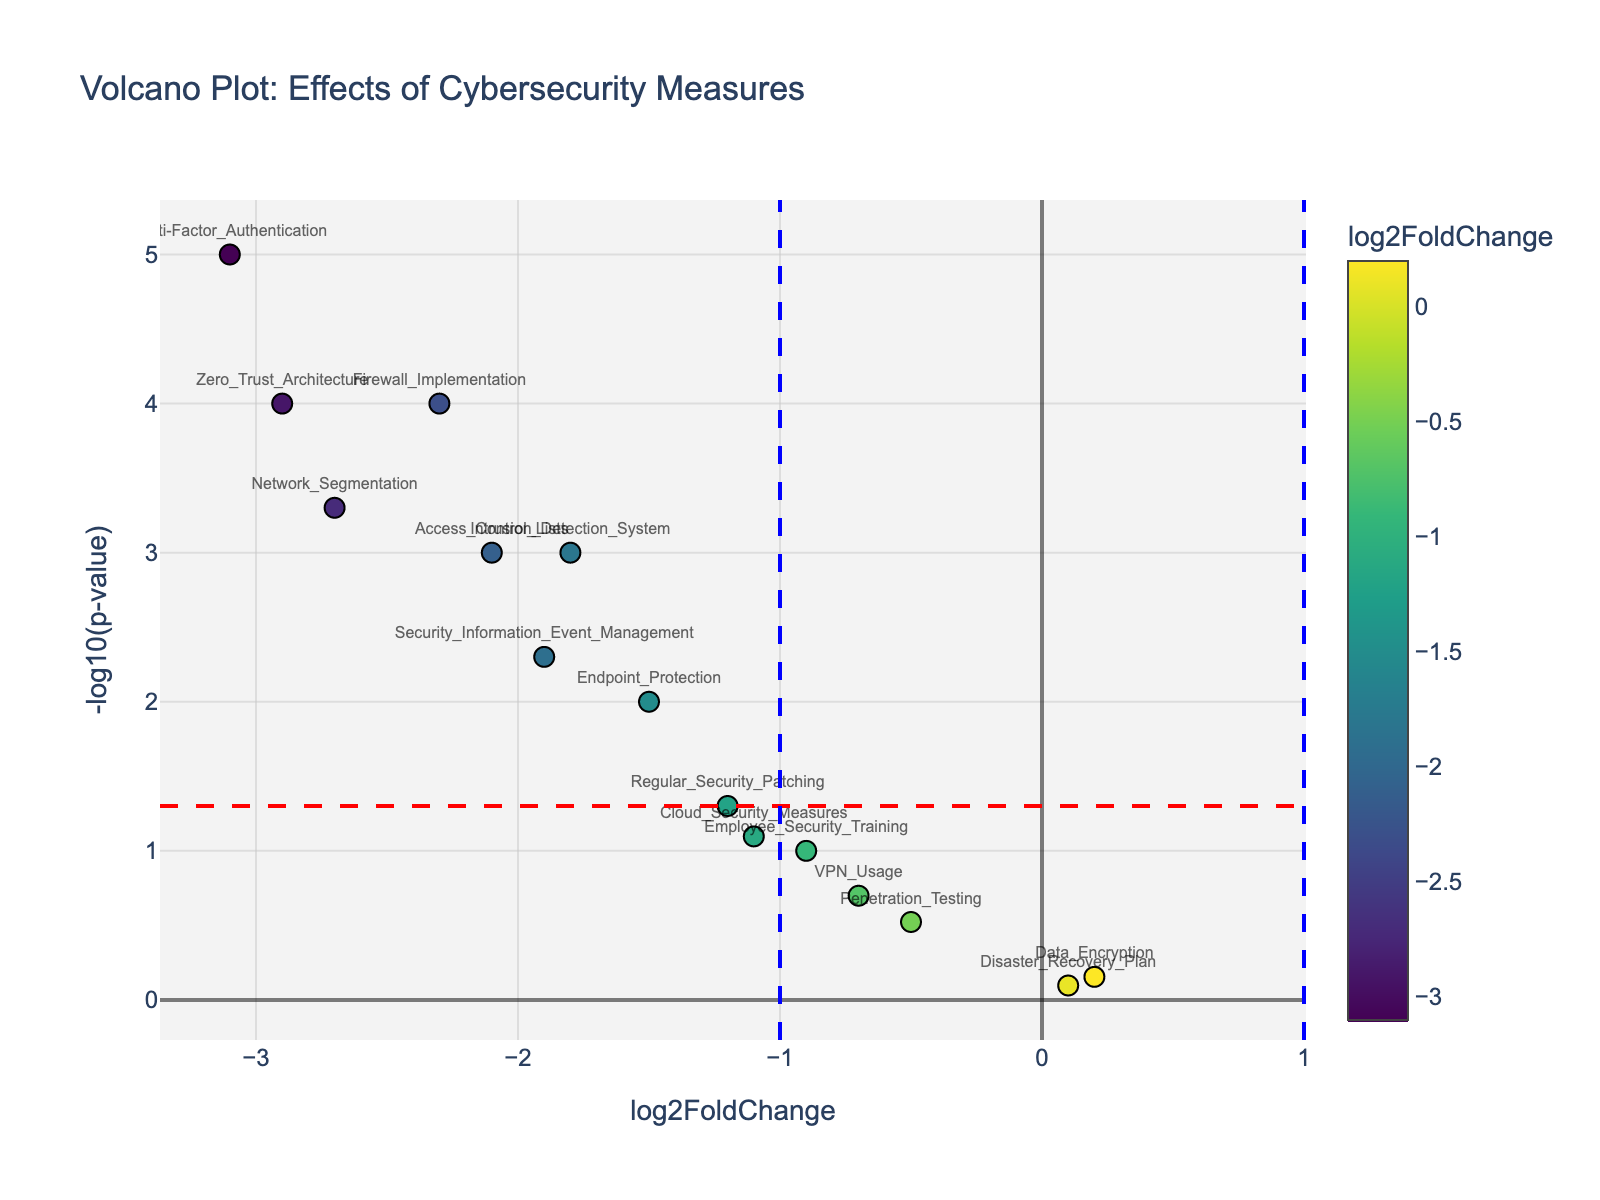What does the title of the plot indicate? The title of the plot indicates the main focus of the data visualization, which in this case is the effects of different cybersecurity measures on network intrusion attempts and successful breaches. By reading the title, you understand that each data point represents a cybersecurity measure, with its effectiveness and significance visualized.
Answer: Effects of Cybersecurity Measures on Network Intrusion Attempts and Successful Breaches Which measure has the highest -log10(p-value) and what is its value? To find the highest -log10(p-value), look for the data point with the highest position on the y-axis. The highest data point appears to be Multi-Factor Authentication, which has the highest -log10(p-value) value.
Answer: Multi-Factor Authentication, 5 How many measures are considered statistically significant (p-value < 0.05)? To determine the statistically significant measures, look for data points above the red horizontal line (which indicates a p-value of 0.05). Counting all the points above this line shows that there are 8 measures considered statistically significant.
Answer: 8 Which cybersecurity measure exhibits the strongest negative effect on network intrusion attempts? The measure with the strongest negative effect is the one with the largest negative log2FoldChange value. By examining the x-axis for the most leftward point, it is found that Multi-Factor Authentication has the strongest negative effect.
Answer: Multi-Factor Authentication What are the approximate log2FoldChange values for Data Encryption and VPN Usage? To find the approximate log2FoldChange values for Data Encryption and VPN Usage, locate these measures on the x-axis and read their positions. Data Encryption is around 0.2, and VPN Usage is around -0.7.
Answer: Data Encryption: 0.2, VPN Usage: -0.7 Which measure has the lowest statistical significance but still results in a negative log2FoldChange? To identify the measure with the lowest statistical significance (highest p-value) that still has a negative log2FoldChange, look for the data point closest to the bottom of the graph below the red line, yet towards the left. This is likely Employee Security Training.
Answer: Employee Security Training Compare the log2FoldChange values of Network Segmentation and Endpoint Protection. Which one has a lower value? To compare, find the positions of Network Segmentation and Endpoint Protection on the x-axis. Network Segmentation has a log2FoldChange of -2.7 while Endpoint Protection has -1.5, meaning Network Segmentation has a lower value.
Answer: Network Segmentation What is the interpretation of a positive log2FoldChange in this context? A positive log2FoldChange indicates an increase in network intrusion attempts or successful breaches when using the corresponding cybersecurity measure, implying that the measure might not be effective or could even be counterproductive in reducing these incidents.
Answer: Increase in network intrusion attempts Are there any measures that do not show a statistically significant effect but still indicate potential importance based on log2FoldChange? To determine this, consider measures where the p-value is greater than 0.05 (below the red threshold line) yet still have a substantial log2FoldChange. Cloud Security Measures with -1.1 shows a potential importance despite not being statistically significant.
Answer: Cloud Security Measures What is the average log2FoldChange for all measures that are statistically significant? First, identify the log2FoldChange for statistically significant measures (p-value < 0.05). These measures are: Firewall Implementation (-2.3), Intrusion Detection System (-1.8), Multi-Factor Authentication (-3.1), Network Segmentation (-2.7), Endpoint Protection (-1.5), Access Control Lists (-2.1), Security Information Event Management (-1.9), and Zero Trust Architecture (-2.9). Calculate their average: (-2.3 + -1.8 + -3.1 + -2.7 + -1.5 + -2.1 + -1.9 + -2.9) / 8 = -2.1625.
Answer: -2.1625 